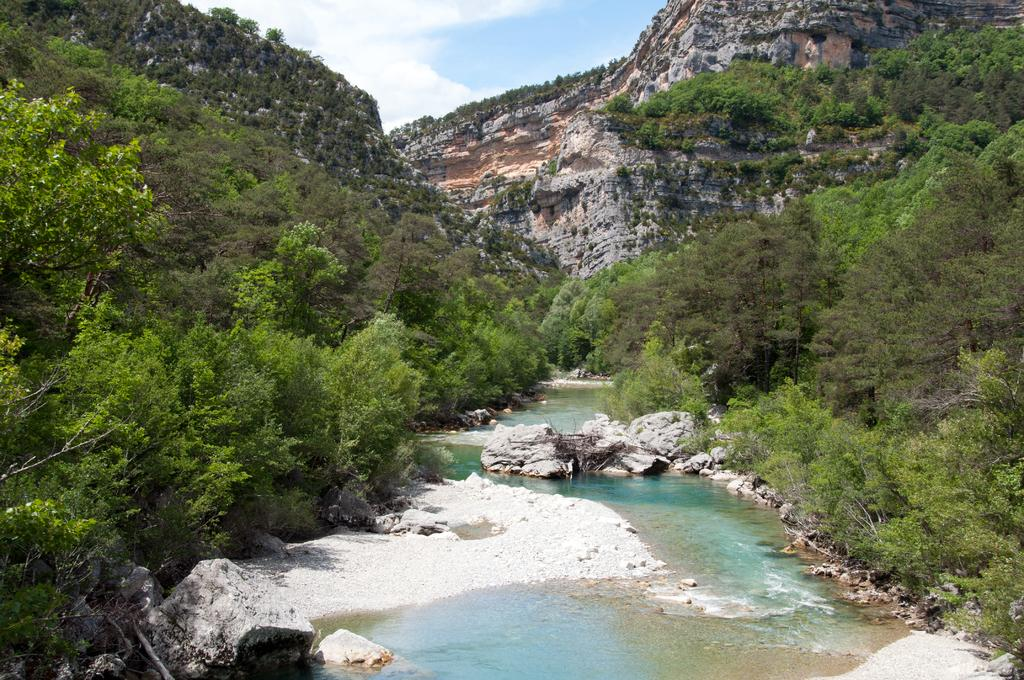What is the main feature in the center of the image? There is water in the center of the image. What can be seen on the right side of the image? There are trees on the right side of the image. What is present on the left side of the image? There are trees on the left side of the image. What else is in the center of the image besides the water? There are rocks in the center of the image. What type of plot is being cultivated in the image? There is no plot or cultivation visible in the image; it primarily features water, trees, and rocks. What color is the orange in the image? There is no orange present in the image. 